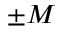Convert formula to latex. <formula><loc_0><loc_0><loc_500><loc_500>\pm M</formula> 